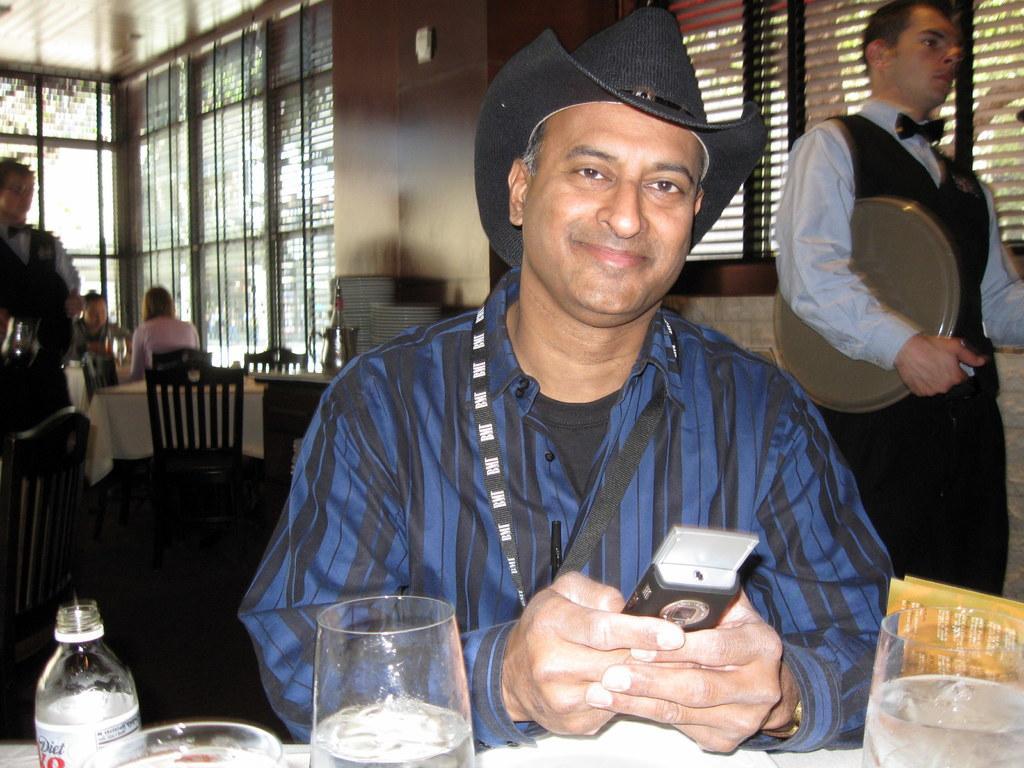How would you summarize this image in a sentence or two? There is a man holding a phone in the center of the image, there are glasses and a bottle at the bottom side, There are chairs, tables, people and windows in the background area. 